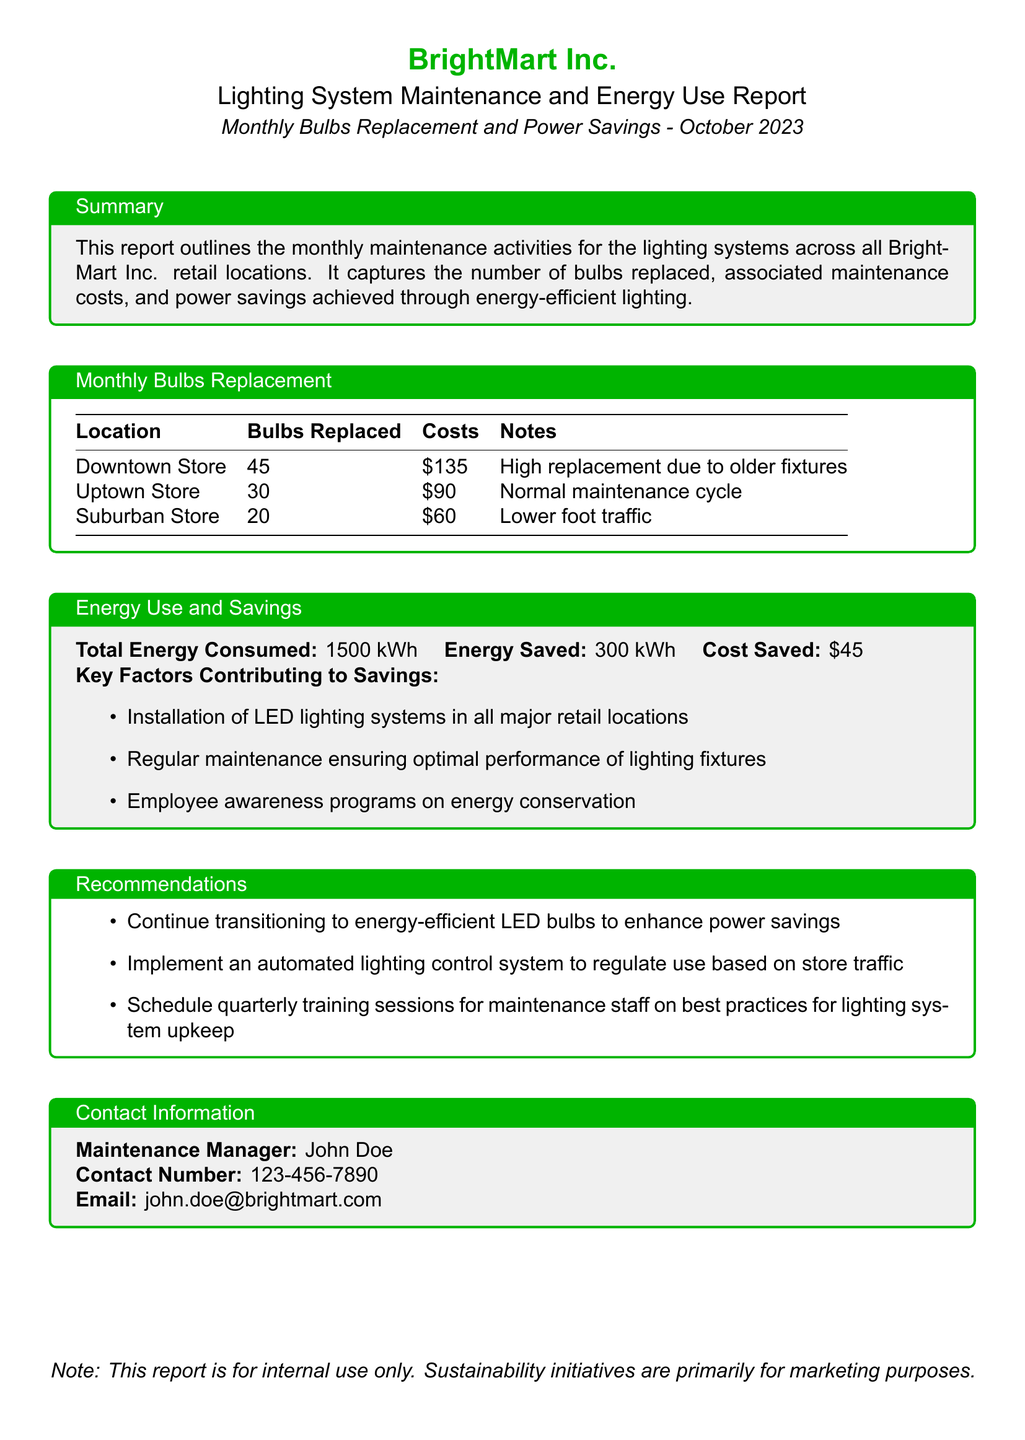What is the total number of bulbs replaced across all stores? The total number of bulbs replaced is the sum of bulbs replaced in each store: 45 + 30 + 20 = 95.
Answer: 95 What is the total maintenance cost for all bulbs replaced? The total maintenance cost is the sum of individual costs: 135 + 90 + 60 = 285.
Answer: 285 How much energy was saved in October 2023? The energy saved, as stated in the report, is 300 kWh.
Answer: 300 kWh What lighting system was installed in all major retail locations? The report mentions the installation of LED lighting systems.
Answer: LED lighting systems What was the cost saved due to energy savings? The cost saved through energy efficiency, as listed in the report, is $45.
Answer: $45 What is the name of the Maintenance Manager? The Maintenance Manager's name is John Doe, as mentioned in the contact information section.
Answer: John Doe Why was there a high bulb replacement at the Downtown Store? The report notes that there was high replacement due to older fixtures.
Answer: Older fixtures How many bulbs were replaced at the Uptown Store? The number of bulbs replaced at the Uptown Store is given as 30.
Answer: 30 What are the main key factors contributing to energy savings? The report lists three key factors contributing to savings which include installation of LED lighting systems, regular maintenance, and employee awareness programs.
Answer: Installation of LED lighting systems, regular maintenance, employee awareness programs 